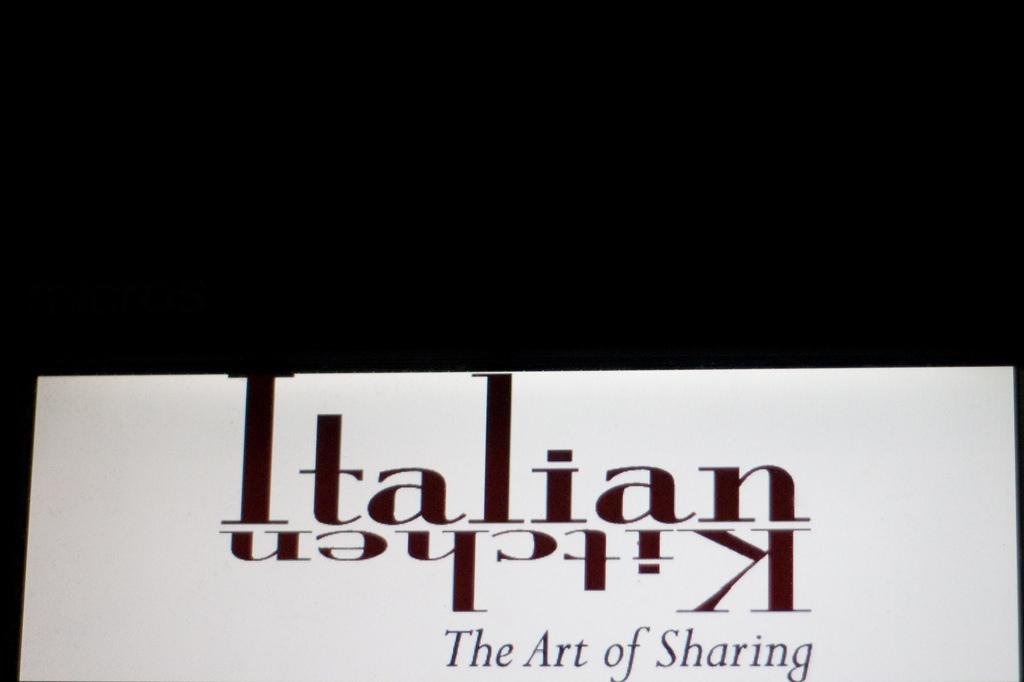<image>
Relay a brief, clear account of the picture shown. Advertisement in White and black for Italian Kitchen the Art of Sharing. 